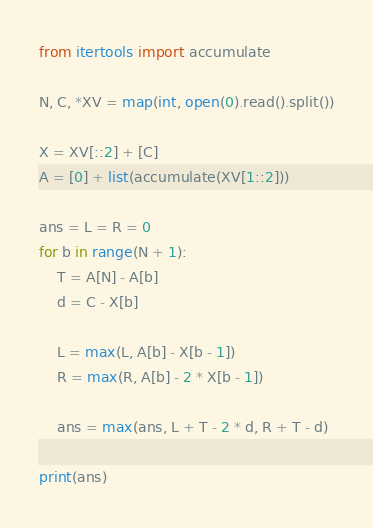Convert code to text. <code><loc_0><loc_0><loc_500><loc_500><_Python_>from itertools import accumulate

N, C, *XV = map(int, open(0).read().split())

X = XV[::2] + [C]
A = [0] + list(accumulate(XV[1::2]))

ans = L = R = 0
for b in range(N + 1):
    T = A[N] - A[b]
    d = C - X[b]

    L = max(L, A[b] - X[b - 1])
    R = max(R, A[b] - 2 * X[b - 1])

    ans = max(ans, L + T - 2 * d, R + T - d)

print(ans)
</code> 